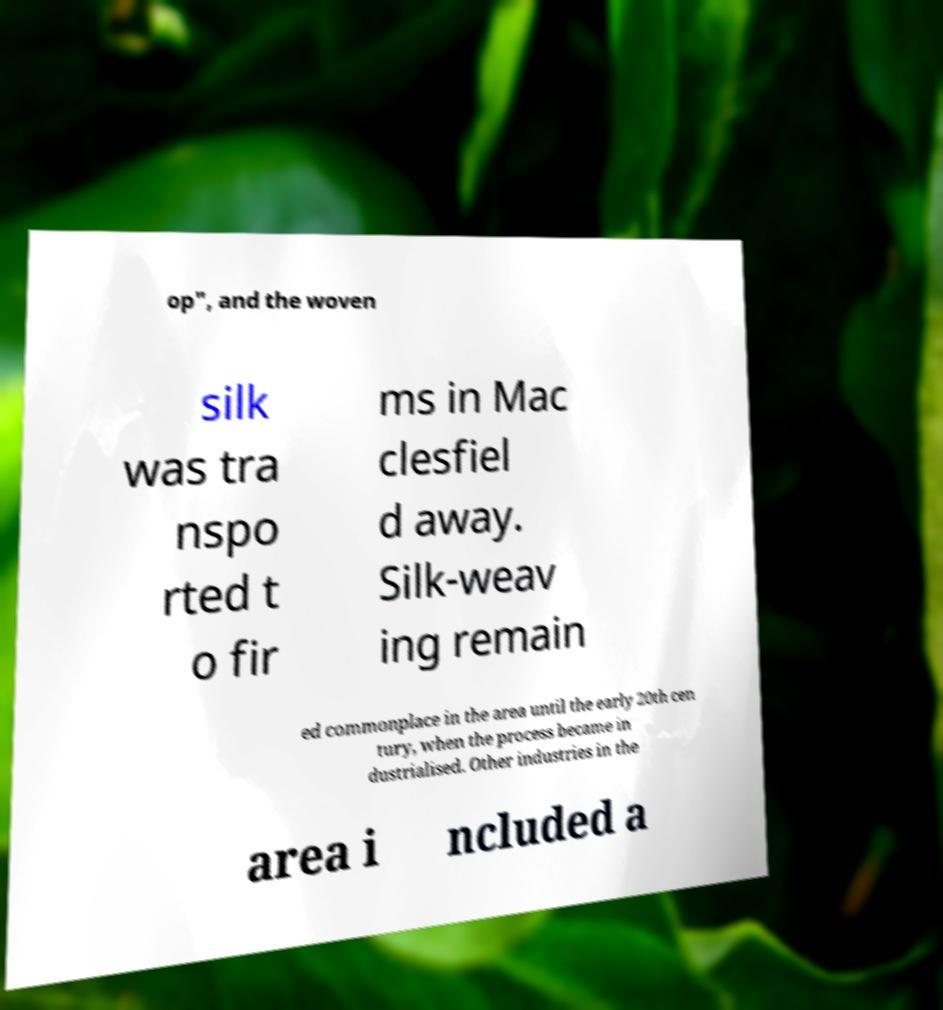Please read and relay the text visible in this image. What does it say? op", and the woven silk was tra nspo rted t o fir ms in Mac clesfiel d away. Silk-weav ing remain ed commonplace in the area until the early 20th cen tury, when the process became in dustrialised. Other industries in the area i ncluded a 